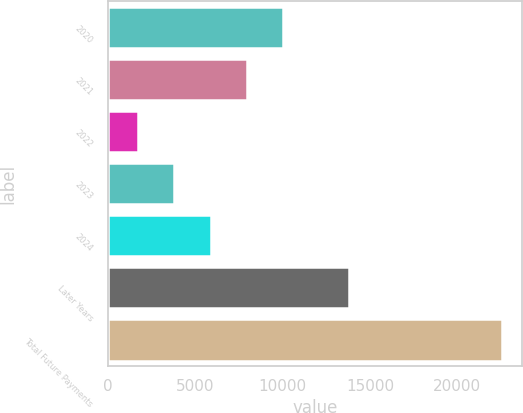Convert chart. <chart><loc_0><loc_0><loc_500><loc_500><bar_chart><fcel>2020<fcel>2021<fcel>2022<fcel>2023<fcel>2024<fcel>Later Years<fcel>Total Future Payments<nl><fcel>10050.6<fcel>7965.2<fcel>1709<fcel>3794.4<fcel>5879.8<fcel>13815<fcel>22563<nl></chart> 